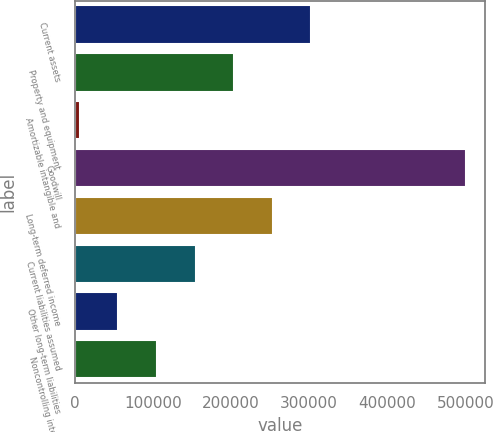Convert chart to OTSL. <chart><loc_0><loc_0><loc_500><loc_500><bar_chart><fcel>Current assets<fcel>Property and equipment<fcel>Amortizable intangible and<fcel>Goodwill<fcel>Long-term deferred income<fcel>Current liabilities assumed<fcel>Other long-term liabilities<fcel>Noncontrolling interests<nl><fcel>303006<fcel>204179<fcel>6523<fcel>500662<fcel>253592<fcel>154765<fcel>55936.9<fcel>105351<nl></chart> 